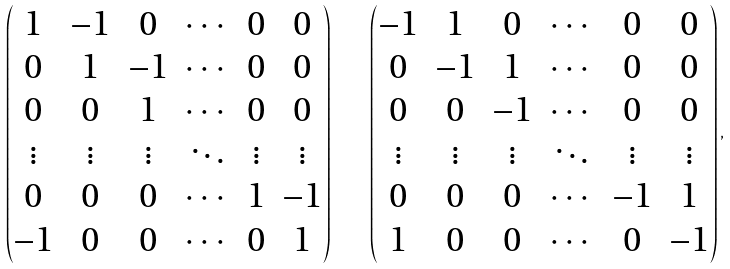<formula> <loc_0><loc_0><loc_500><loc_500>\begin{pmatrix} 1 & - 1 & 0 & \cdots & 0 & 0 \\ 0 & 1 & - 1 & \cdots & 0 & 0 \\ 0 & 0 & 1 & \cdots & 0 & 0 \\ \vdots & \vdots & \vdots & \ddots & \vdots & \vdots \\ 0 & 0 & 0 & \cdots & 1 & - 1 \\ - 1 & 0 & 0 & \cdots & 0 & 1 \end{pmatrix} \quad \begin{pmatrix} - 1 & 1 & 0 & \cdots & 0 & 0 \\ 0 & - 1 & 1 & \cdots & 0 & 0 \\ 0 & 0 & - 1 & \cdots & 0 & 0 \\ \vdots & \vdots & \vdots & \ddots & \vdots & \vdots \\ 0 & 0 & 0 & \cdots & - 1 & 1 \\ 1 & 0 & 0 & \cdots & 0 & - 1 \end{pmatrix} ,</formula> 